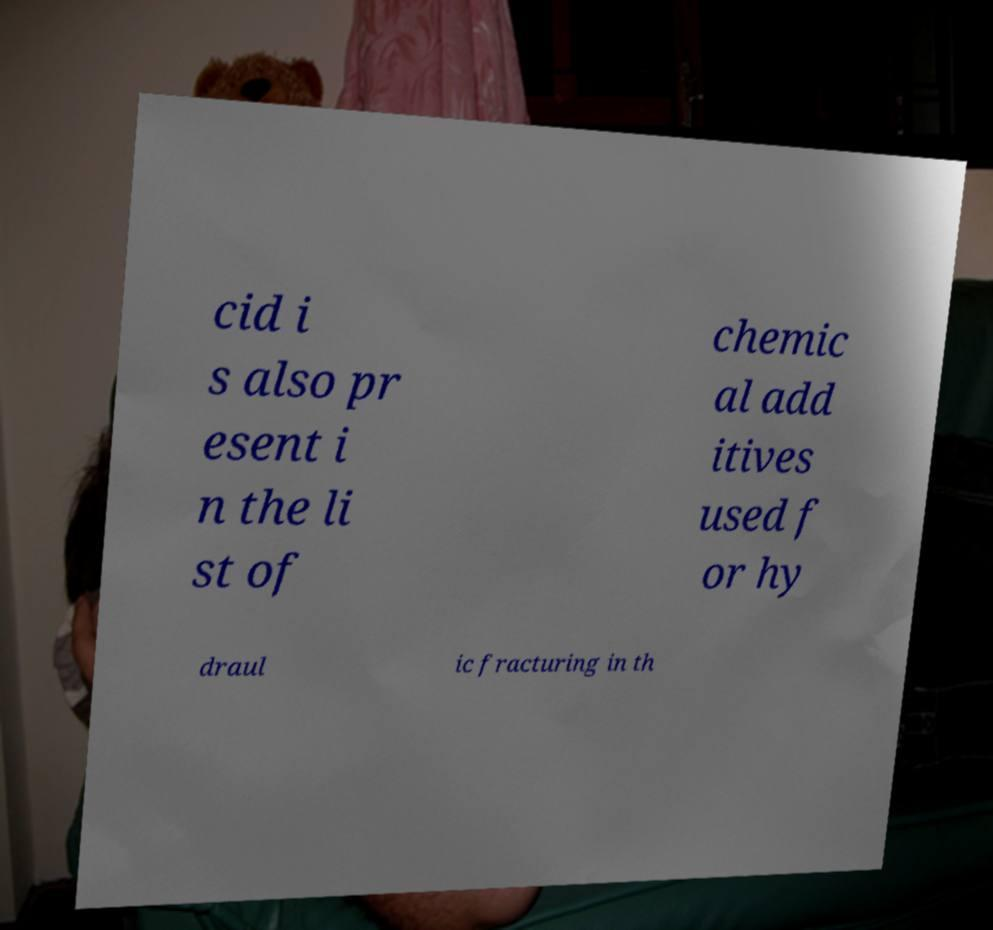Can you read and provide the text displayed in the image?This photo seems to have some interesting text. Can you extract and type it out for me? cid i s also pr esent i n the li st of chemic al add itives used f or hy draul ic fracturing in th 